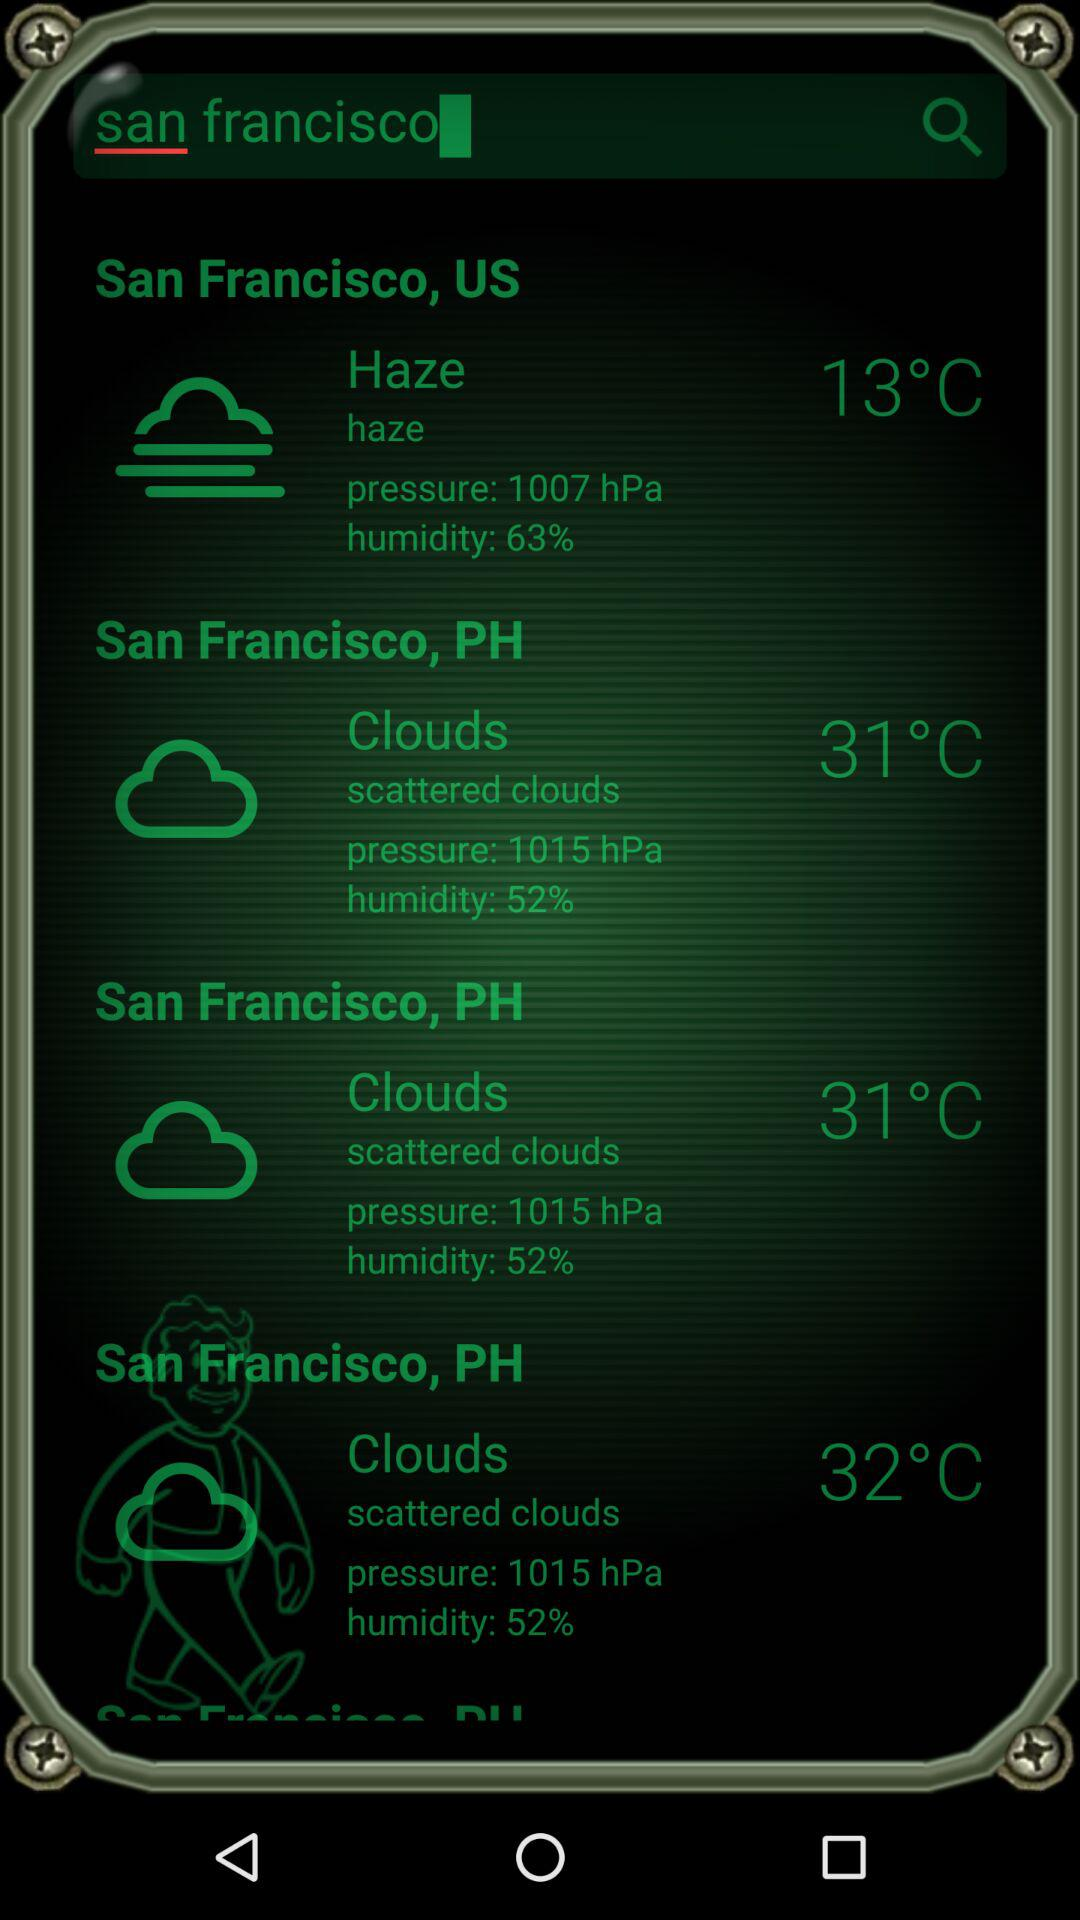What is the pressure of haze? The pressure of haze is 1007 hPa. 